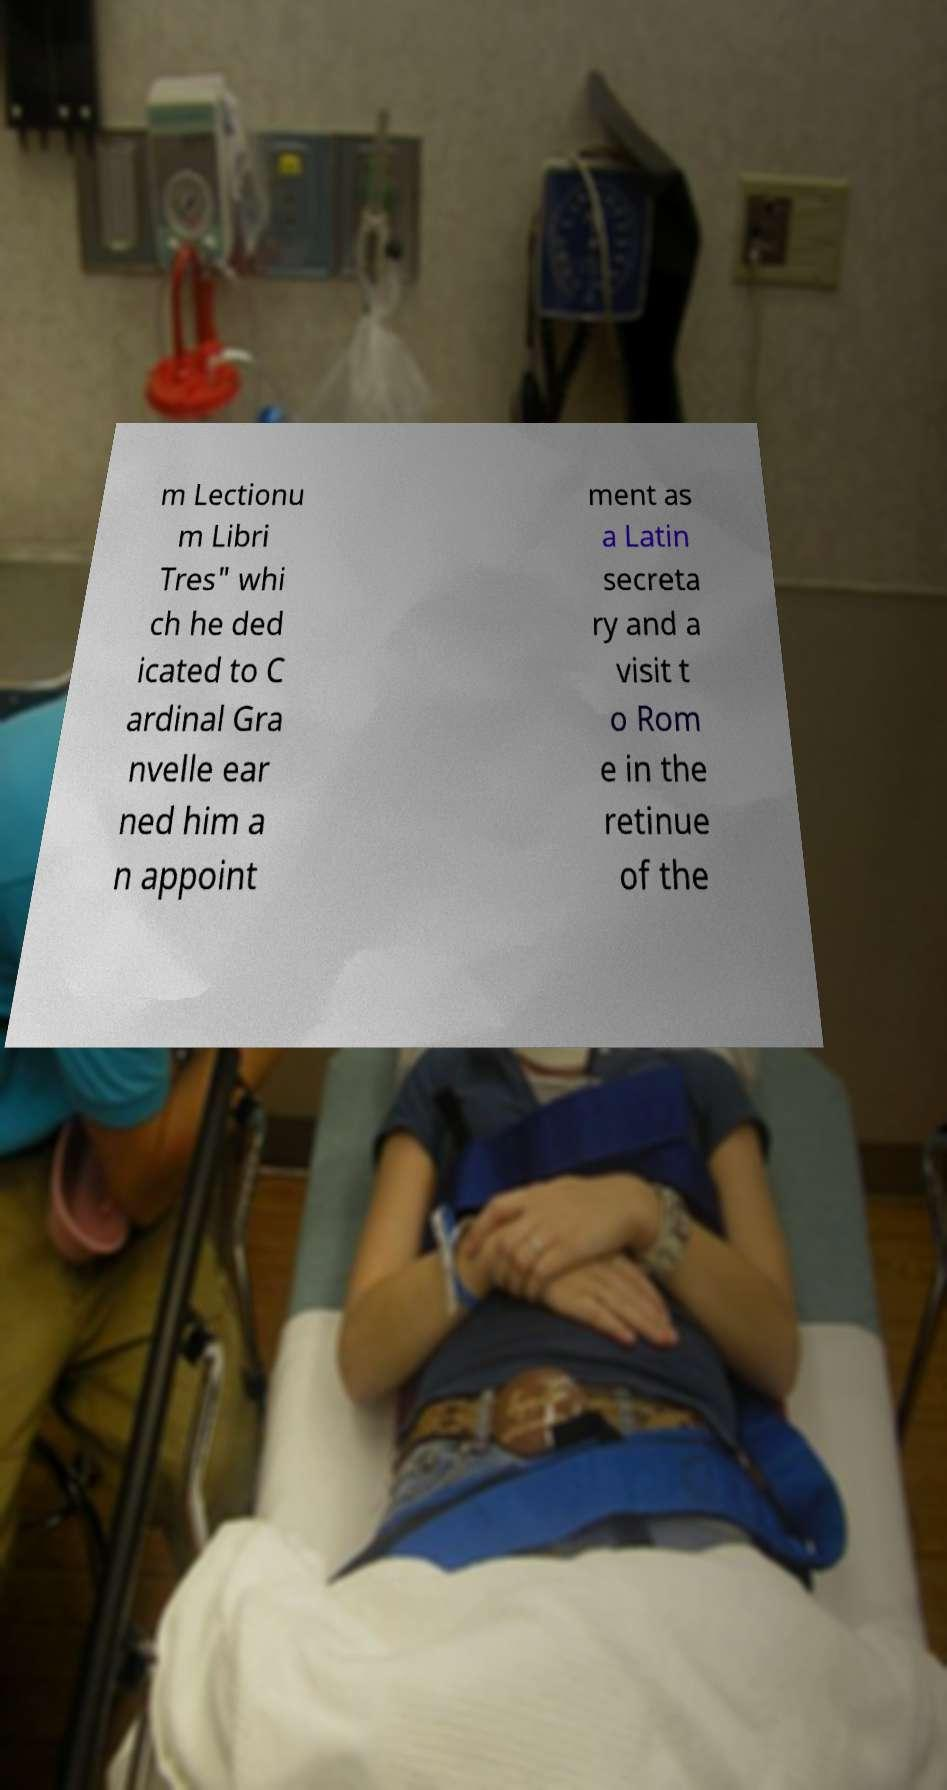For documentation purposes, I need the text within this image transcribed. Could you provide that? m Lectionu m Libri Tres" whi ch he ded icated to C ardinal Gra nvelle ear ned him a n appoint ment as a Latin secreta ry and a visit t o Rom e in the retinue of the 